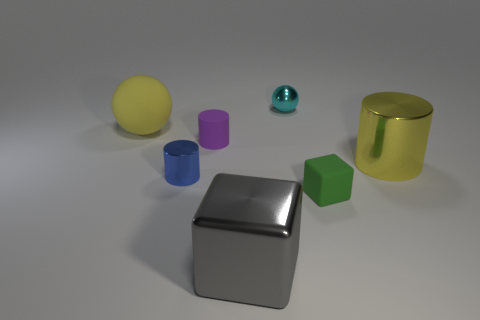The green thing is what size?
Make the answer very short. Small. There is a big ball that is the same material as the tiny purple cylinder; what is its color?
Your answer should be compact. Yellow. How many large brown things are the same material as the big yellow ball?
Offer a very short reply. 0. How many objects are either yellow rubber balls or large cylinders that are in front of the purple matte thing?
Your answer should be very brief. 2. Do the yellow object that is left of the yellow shiny thing and the cyan sphere have the same material?
Provide a short and direct response. No. There is a metallic sphere that is the same size as the blue thing; what color is it?
Provide a short and direct response. Cyan. Are there any tiny purple objects that have the same shape as the gray thing?
Give a very brief answer. No. There is a rubber object that is in front of the yellow thing in front of the tiny matte object to the left of the large metal cube; what color is it?
Provide a succinct answer. Green. How many shiny objects are big blocks or blue cylinders?
Provide a short and direct response. 2. Is the number of small cyan metal balls on the left side of the small metallic ball greater than the number of large balls that are in front of the gray block?
Keep it short and to the point. No. 